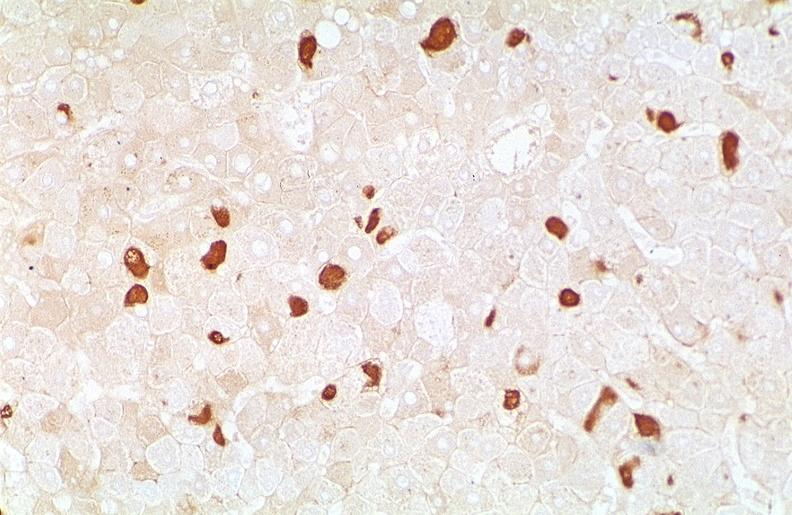what is present?
Answer the question using a single word or phrase. Hepatobiliary 